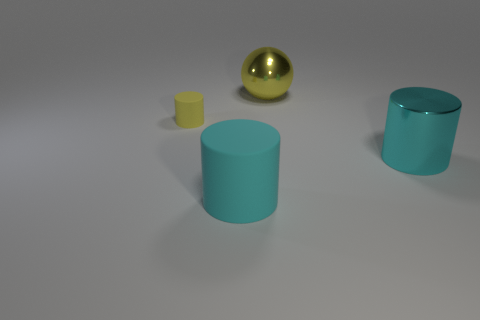Is there anything in this scene that indicates it might be part of a larger setting or story? The arrangement of objects could imply a minimalist setting, possibly part of a size comparison demonstration or a visual aesthetics study.  What do you think is the association between the objects? The objects could represent different elements within a comparative study, like a demonstration on volume, color contrasts, or material properties in a controlled environment. 